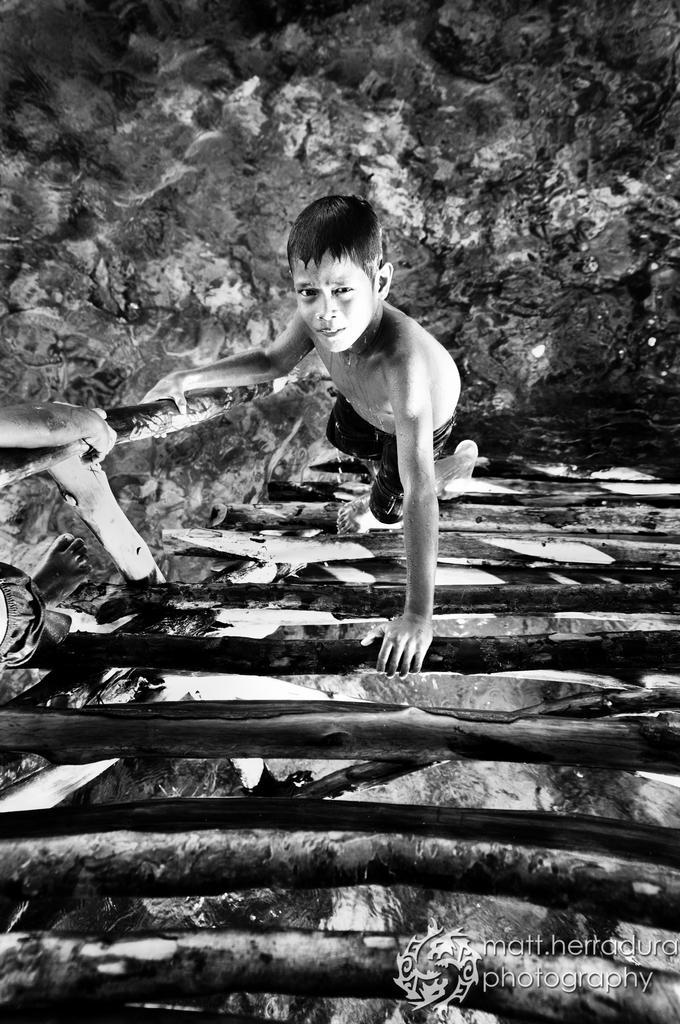Could you give a brief overview of what you see in this image? In this picture I can see a boy. This picture is black and white in color. 